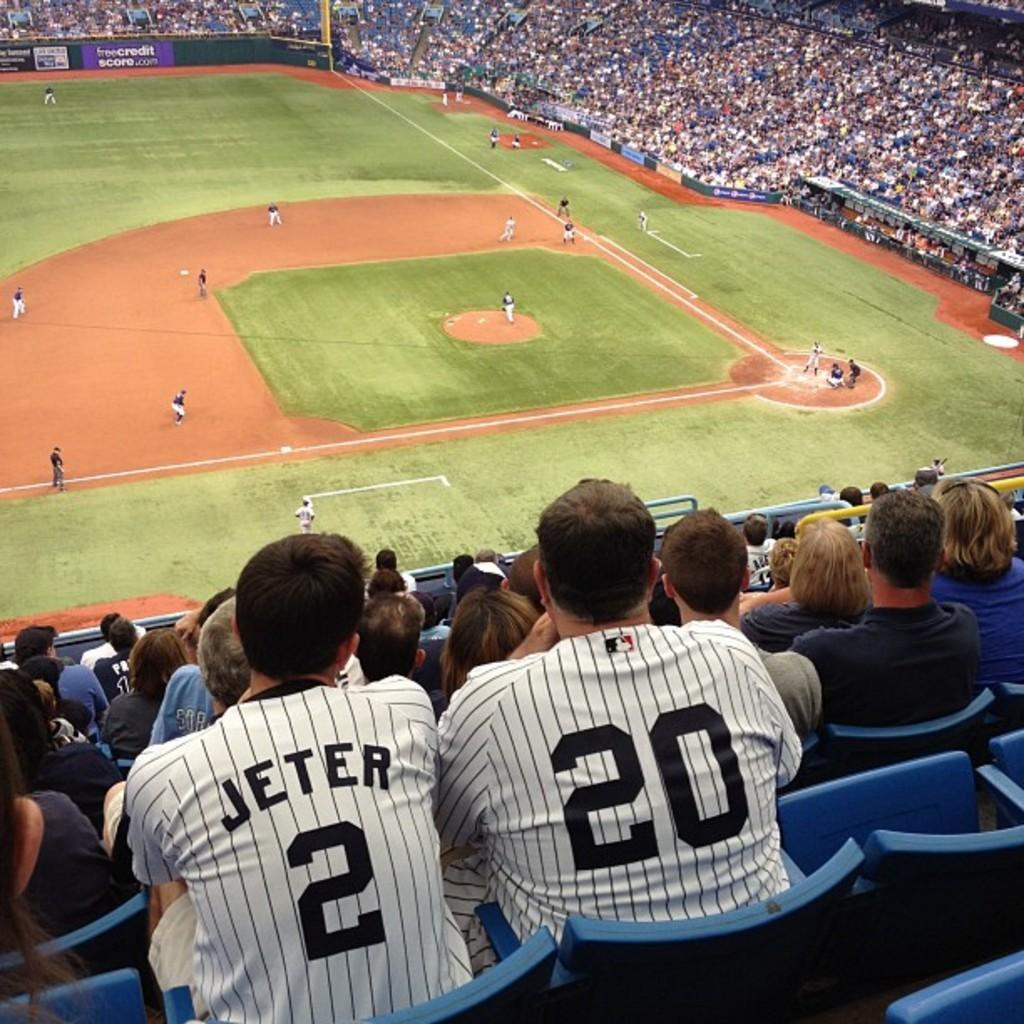<image>
Provide a brief description of the given image. The man watched the baseball game as he wore his Jeter jersey. 